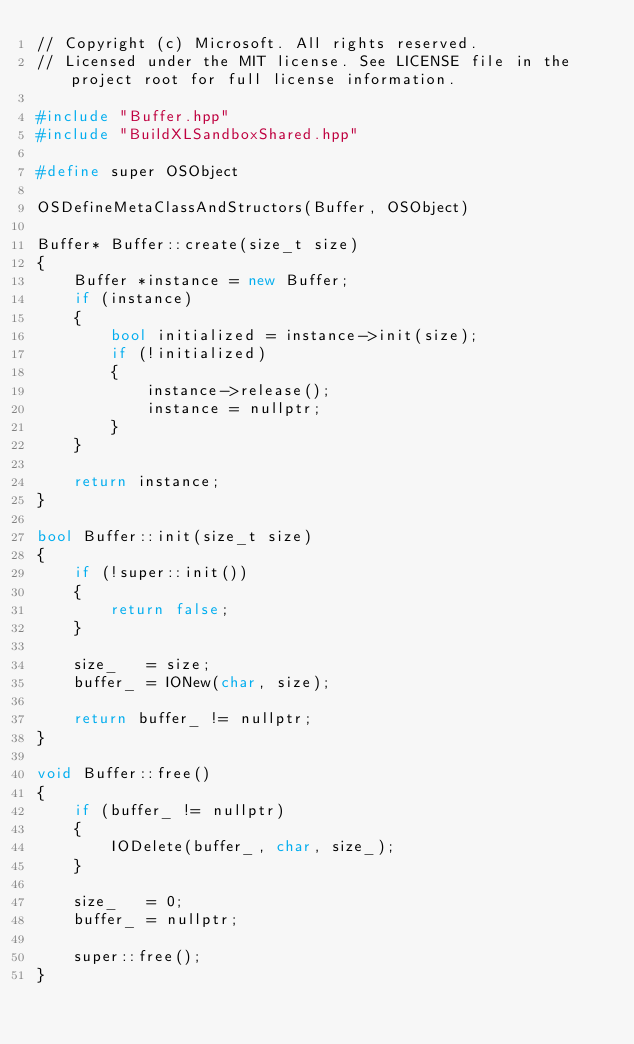<code> <loc_0><loc_0><loc_500><loc_500><_C++_>// Copyright (c) Microsoft. All rights reserved.
// Licensed under the MIT license. See LICENSE file in the project root for full license information.

#include "Buffer.hpp"
#include "BuildXLSandboxShared.hpp"

#define super OSObject

OSDefineMetaClassAndStructors(Buffer, OSObject)

Buffer* Buffer::create(size_t size)
{
    Buffer *instance = new Buffer;
    if (instance)
    {
        bool initialized = instance->init(size);
        if (!initialized)
        {
            instance->release();
            instance = nullptr;
        }
    }

    return instance;
}

bool Buffer::init(size_t size)
{
    if (!super::init())
    {
        return false;
    }

    size_   = size;
    buffer_ = IONew(char, size);

    return buffer_ != nullptr;
}

void Buffer::free()
{
    if (buffer_ != nullptr)
    {
        IODelete(buffer_, char, size_);
    }

    size_   = 0;
    buffer_ = nullptr;

    super::free();
}
</code> 